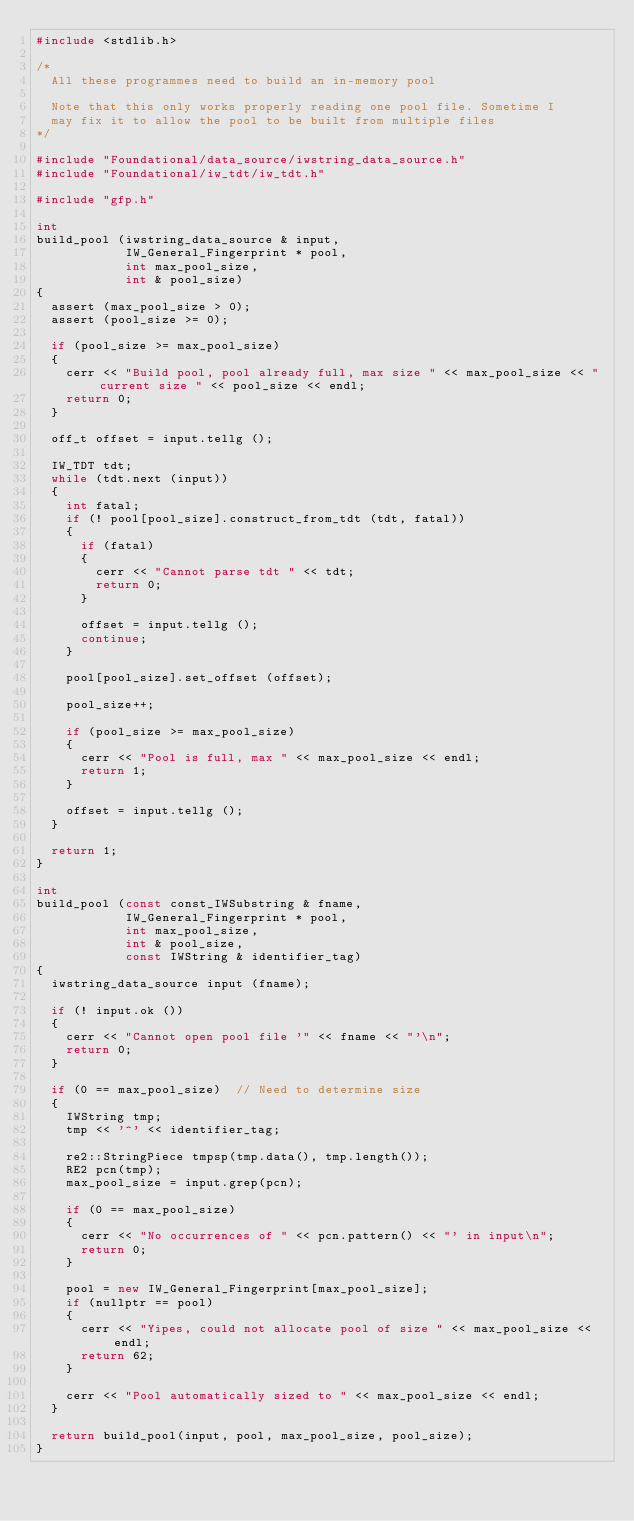Convert code to text. <code><loc_0><loc_0><loc_500><loc_500><_C++_>#include <stdlib.h>

/*
  All these programmes need to build an in-memory pool

  Note that this only works properly reading one pool file. Sometime I
  may fix it to allow the pool to be built from multiple files
*/

#include "Foundational/data_source/iwstring_data_source.h"
#include "Foundational/iw_tdt/iw_tdt.h"

#include "gfp.h"

int
build_pool (iwstring_data_source & input,
            IW_General_Fingerprint * pool,
            int max_pool_size,
            int & pool_size)
{
  assert (max_pool_size > 0);
  assert (pool_size >= 0);

  if (pool_size >= max_pool_size)
  {
    cerr << "Build pool, pool already full, max size " << max_pool_size << " current size " << pool_size << endl;
    return 0;
  }

  off_t offset = input.tellg ();

  IW_TDT tdt;
  while (tdt.next (input))
  {
    int fatal;
    if (! pool[pool_size].construct_from_tdt (tdt, fatal))
    {
      if (fatal)
      {
        cerr << "Cannot parse tdt " << tdt;
        return 0;
      }

      offset = input.tellg ();
      continue;
    }

    pool[pool_size].set_offset (offset);

    pool_size++;

    if (pool_size >= max_pool_size)
    {
      cerr << "Pool is full, max " << max_pool_size << endl;
      return 1;
    }

    offset = input.tellg ();
  }

  return 1;
}

int
build_pool (const const_IWSubstring & fname,
            IW_General_Fingerprint * pool,
            int max_pool_size,
            int & pool_size,
            const IWString & identifier_tag)
{
  iwstring_data_source input (fname);

  if (! input.ok ())
  {
    cerr << "Cannot open pool file '" << fname << "'\n";
    return 0;
  }

  if (0 == max_pool_size)  // Need to determine size
  {
    IWString tmp;
    tmp << '^' << identifier_tag;

    re2::StringPiece tmpsp(tmp.data(), tmp.length());
    RE2 pcn(tmp);
    max_pool_size = input.grep(pcn);

    if (0 == max_pool_size)
    {
      cerr << "No occurrences of " << pcn.pattern() << "' in input\n";
      return 0;
    }

    pool = new IW_General_Fingerprint[max_pool_size];
    if (nullptr == pool)
    {
      cerr << "Yipes, could not allocate pool of size " << max_pool_size << endl;
      return 62;
    }

    cerr << "Pool automatically sized to " << max_pool_size << endl;
  }

  return build_pool(input, pool, max_pool_size, pool_size);
}
</code> 